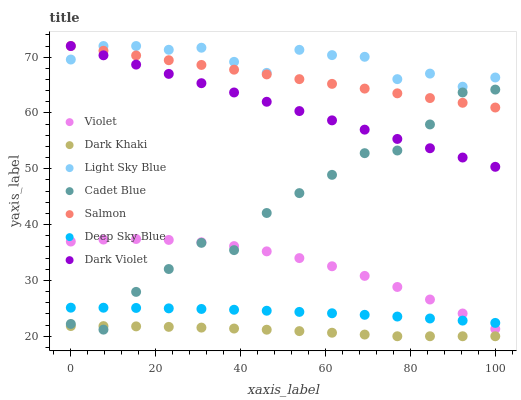Does Dark Khaki have the minimum area under the curve?
Answer yes or no. Yes. Does Light Sky Blue have the maximum area under the curve?
Answer yes or no. Yes. Does Salmon have the minimum area under the curve?
Answer yes or no. No. Does Salmon have the maximum area under the curve?
Answer yes or no. No. Is Dark Violet the smoothest?
Answer yes or no. Yes. Is Cadet Blue the roughest?
Answer yes or no. Yes. Is Salmon the smoothest?
Answer yes or no. No. Is Salmon the roughest?
Answer yes or no. No. Does Dark Khaki have the lowest value?
Answer yes or no. Yes. Does Salmon have the lowest value?
Answer yes or no. No. Does Light Sky Blue have the highest value?
Answer yes or no. Yes. Does Dark Khaki have the highest value?
Answer yes or no. No. Is Violet less than Light Sky Blue?
Answer yes or no. Yes. Is Dark Violet greater than Dark Khaki?
Answer yes or no. Yes. Does Light Sky Blue intersect Salmon?
Answer yes or no. Yes. Is Light Sky Blue less than Salmon?
Answer yes or no. No. Is Light Sky Blue greater than Salmon?
Answer yes or no. No. Does Violet intersect Light Sky Blue?
Answer yes or no. No. 